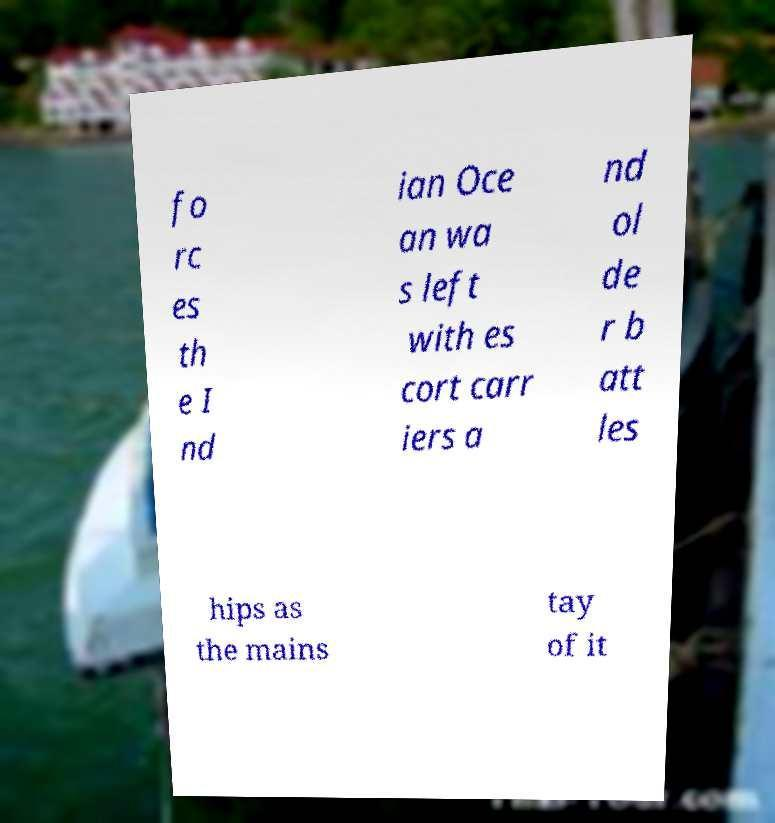Can you accurately transcribe the text from the provided image for me? fo rc es th e I nd ian Oce an wa s left with es cort carr iers a nd ol de r b att les hips as the mains tay of it 